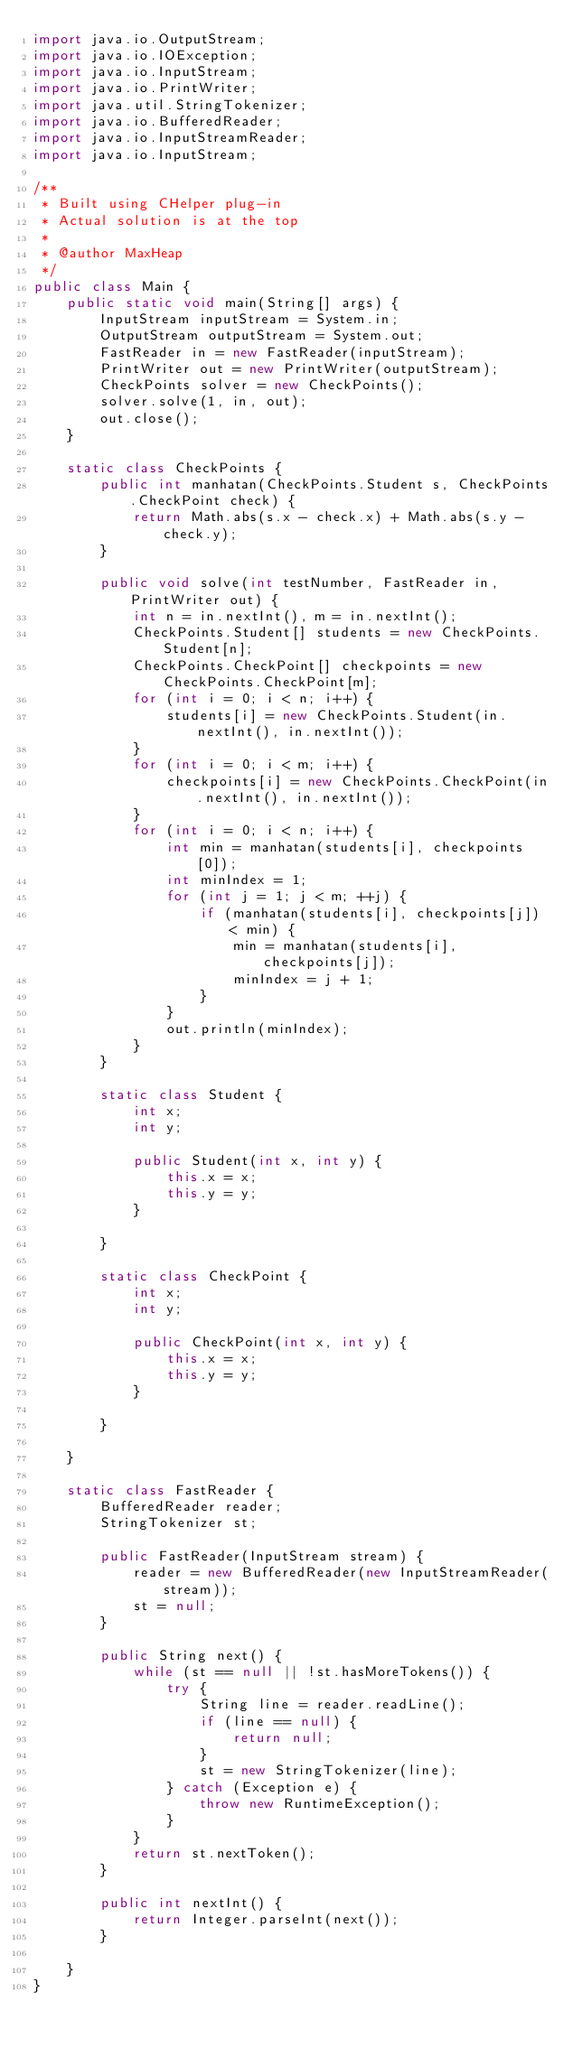Convert code to text. <code><loc_0><loc_0><loc_500><loc_500><_Java_>import java.io.OutputStream;
import java.io.IOException;
import java.io.InputStream;
import java.io.PrintWriter;
import java.util.StringTokenizer;
import java.io.BufferedReader;
import java.io.InputStreamReader;
import java.io.InputStream;

/**
 * Built using CHelper plug-in
 * Actual solution is at the top
 *
 * @author MaxHeap
 */
public class Main {
    public static void main(String[] args) {
        InputStream inputStream = System.in;
        OutputStream outputStream = System.out;
        FastReader in = new FastReader(inputStream);
        PrintWriter out = new PrintWriter(outputStream);
        CheckPoints solver = new CheckPoints();
        solver.solve(1, in, out);
        out.close();
    }

    static class CheckPoints {
        public int manhatan(CheckPoints.Student s, CheckPoints.CheckPoint check) {
            return Math.abs(s.x - check.x) + Math.abs(s.y - check.y);
        }

        public void solve(int testNumber, FastReader in, PrintWriter out) {
            int n = in.nextInt(), m = in.nextInt();
            CheckPoints.Student[] students = new CheckPoints.Student[n];
            CheckPoints.CheckPoint[] checkpoints = new CheckPoints.CheckPoint[m];
            for (int i = 0; i < n; i++) {
                students[i] = new CheckPoints.Student(in.nextInt(), in.nextInt());
            }
            for (int i = 0; i < m; i++) {
                checkpoints[i] = new CheckPoints.CheckPoint(in.nextInt(), in.nextInt());
            }
            for (int i = 0; i < n; i++) {
                int min = manhatan(students[i], checkpoints[0]);
                int minIndex = 1;
                for (int j = 1; j < m; ++j) {
                    if (manhatan(students[i], checkpoints[j]) < min) {
                        min = manhatan(students[i], checkpoints[j]);
                        minIndex = j + 1;
                    }
                }
                out.println(minIndex);
            }
        }

        static class Student {
            int x;
            int y;

            public Student(int x, int y) {
                this.x = x;
                this.y = y;
            }

        }

        static class CheckPoint {
            int x;
            int y;

            public CheckPoint(int x, int y) {
                this.x = x;
                this.y = y;
            }

        }

    }

    static class FastReader {
        BufferedReader reader;
        StringTokenizer st;

        public FastReader(InputStream stream) {
            reader = new BufferedReader(new InputStreamReader(stream));
            st = null;
        }

        public String next() {
            while (st == null || !st.hasMoreTokens()) {
                try {
                    String line = reader.readLine();
                    if (line == null) {
                        return null;
                    }
                    st = new StringTokenizer(line);
                } catch (Exception e) {
                    throw new RuntimeException();
                }
            }
            return st.nextToken();
        }

        public int nextInt() {
            return Integer.parseInt(next());
        }

    }
}

</code> 